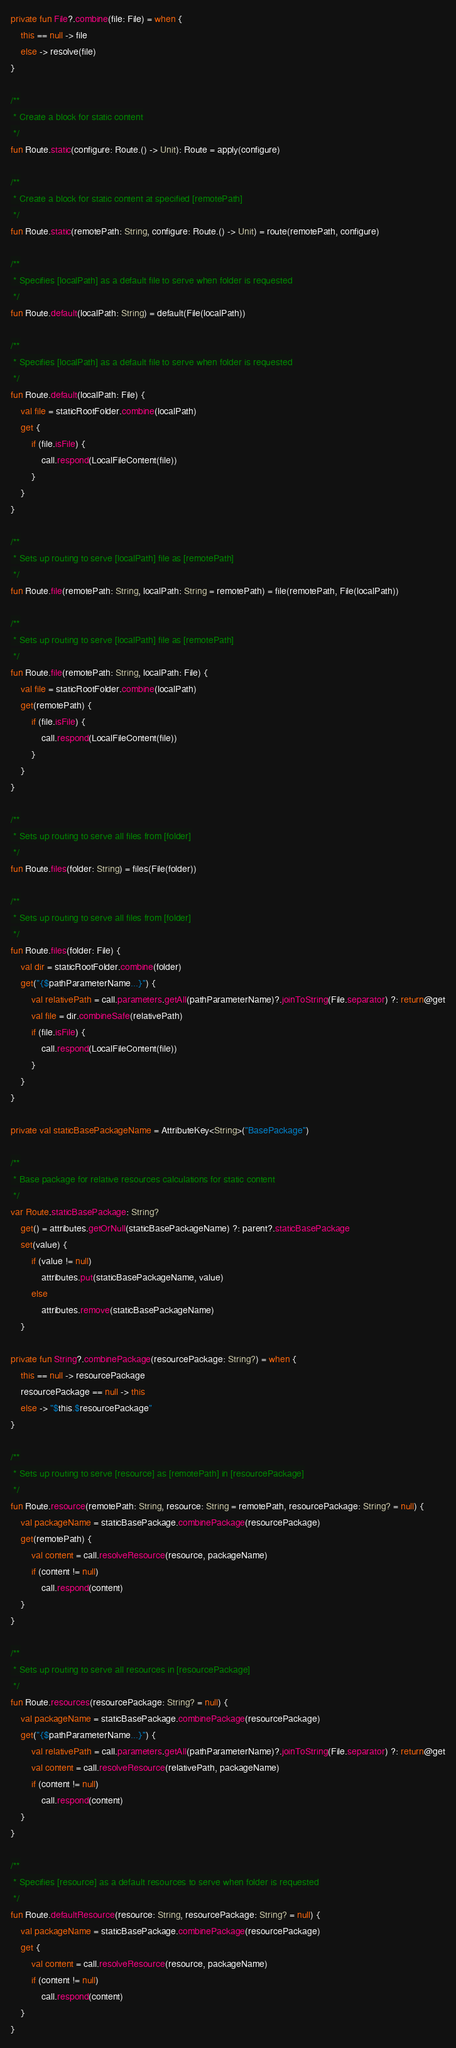<code> <loc_0><loc_0><loc_500><loc_500><_Kotlin_>
private fun File?.combine(file: File) = when {
    this == null -> file
    else -> resolve(file)
}

/**
 * Create a block for static content
 */
fun Route.static(configure: Route.() -> Unit): Route = apply(configure)

/**
 * Create a block for static content at specified [remotePath]
 */
fun Route.static(remotePath: String, configure: Route.() -> Unit) = route(remotePath, configure)

/**
 * Specifies [localPath] as a default file to serve when folder is requested
 */
fun Route.default(localPath: String) = default(File(localPath))

/**
 * Specifies [localPath] as a default file to serve when folder is requested
 */
fun Route.default(localPath: File) {
    val file = staticRootFolder.combine(localPath)
    get {
        if (file.isFile) {
            call.respond(LocalFileContent(file))
        }
    }
}

/**
 * Sets up routing to serve [localPath] file as [remotePath]
 */
fun Route.file(remotePath: String, localPath: String = remotePath) = file(remotePath, File(localPath))

/**
 * Sets up routing to serve [localPath] file as [remotePath]
 */
fun Route.file(remotePath: String, localPath: File) {
    val file = staticRootFolder.combine(localPath)
    get(remotePath) {
        if (file.isFile) {
            call.respond(LocalFileContent(file))
        }
    }
}

/**
 * Sets up routing to serve all files from [folder]
 */
fun Route.files(folder: String) = files(File(folder))

/**
 * Sets up routing to serve all files from [folder]
 */
fun Route.files(folder: File) {
    val dir = staticRootFolder.combine(folder)
    get("{$pathParameterName...}") {
        val relativePath = call.parameters.getAll(pathParameterName)?.joinToString(File.separator) ?: return@get
        val file = dir.combineSafe(relativePath)
        if (file.isFile) {
            call.respond(LocalFileContent(file))
        }
    }
}

private val staticBasePackageName = AttributeKey<String>("BasePackage")

/**
 * Base package for relative resources calculations for static content
 */
var Route.staticBasePackage: String?
    get() = attributes.getOrNull(staticBasePackageName) ?: parent?.staticBasePackage
    set(value) {
        if (value != null)
            attributes.put(staticBasePackageName, value)
        else
            attributes.remove(staticBasePackageName)
    }

private fun String?.combinePackage(resourcePackage: String?) = when {
    this == null -> resourcePackage
    resourcePackage == null -> this
    else -> "$this.$resourcePackage"
}

/**
 * Sets up routing to serve [resource] as [remotePath] in [resourcePackage]
 */
fun Route.resource(remotePath: String, resource: String = remotePath, resourcePackage: String? = null) {
    val packageName = staticBasePackage.combinePackage(resourcePackage)
    get(remotePath) {
        val content = call.resolveResource(resource, packageName)
        if (content != null)
            call.respond(content)
    }
}

/**
 * Sets up routing to serve all resources in [resourcePackage]
 */
fun Route.resources(resourcePackage: String? = null) {
    val packageName = staticBasePackage.combinePackage(resourcePackage)
    get("{$pathParameterName...}") {
        val relativePath = call.parameters.getAll(pathParameterName)?.joinToString(File.separator) ?: return@get
        val content = call.resolveResource(relativePath, packageName)
        if (content != null)
            call.respond(content)
    }
}

/**
 * Specifies [resource] as a default resources to serve when folder is requested
 */
fun Route.defaultResource(resource: String, resourcePackage: String? = null) {
    val packageName = staticBasePackage.combinePackage(resourcePackage)
    get {
        val content = call.resolveResource(resource, packageName)
        if (content != null)
            call.respond(content)
    }
}
</code> 